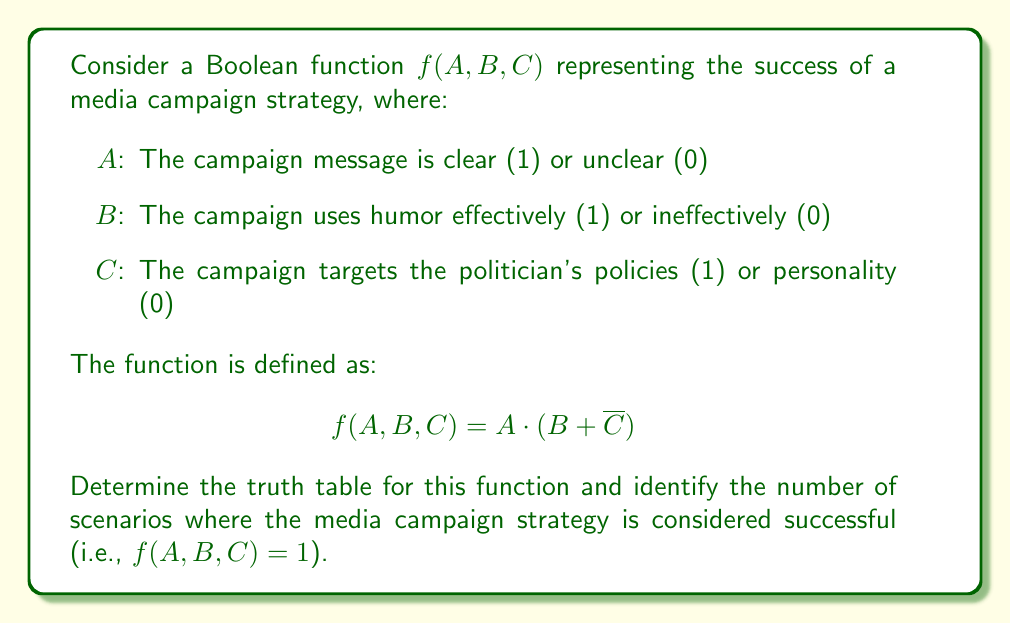Can you solve this math problem? To solve this problem, we need to create a truth table for the given Boolean function and count the number of times the output is 1.

Step 1: Create the truth table
We have 3 variables (A, B, C), so our truth table will have $2^3 = 8$ rows.

| A | B | C | $\overline{C}$ | $B + \overline{C}$ | $f(A, B, C) = A \cdot (B + \overline{C})$ |
|---|---|---|---------------|---------------------|---------------------------------------------|
| 0 | 0 | 0 | 1             | 1                   | 0                                           |
| 0 | 0 | 1 | 0             | 0                   | 0                                           |
| 0 | 1 | 0 | 1             | 1                   | 0                                           |
| 0 | 1 | 1 | 0             | 1                   | 0                                           |
| 1 | 0 | 0 | 1             | 1                   | 1                                           |
| 1 | 0 | 1 | 0             | 0                   | 0                                           |
| 1 | 1 | 0 | 1             | 1                   | 1                                           |
| 1 | 1 | 1 | 0             | 1                   | 1                                           |

Step 2: Count the number of successful scenarios
From the truth table, we can see that $f(A, B, C) = 1$ occurs 3 times.

These scenarios are:
1. When A = 1, B = 0, C = 0 (clear message, ineffective humor, targeting policies)
2. When A = 1, B = 1, C = 0 (clear message, effective humor, targeting policies)
3. When A = 1, B = 1, C = 1 (clear message, effective humor, targeting personality)

This result suggests that a clear message (A = 1) is crucial for the campaign's success, while effective humor or targeting policies can contribute to success when the message is clear.
Answer: 3 